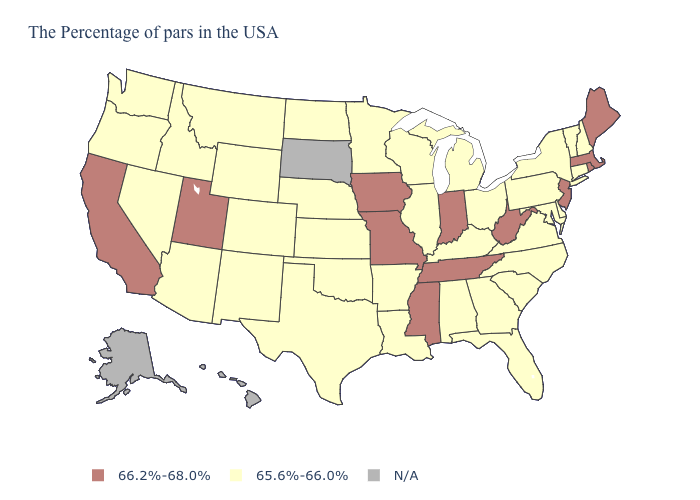What is the highest value in the USA?
Be succinct. 66.2%-68.0%. What is the lowest value in the USA?
Answer briefly. 65.6%-66.0%. Which states have the lowest value in the USA?
Concise answer only. New Hampshire, Vermont, Connecticut, New York, Delaware, Maryland, Pennsylvania, Virginia, North Carolina, South Carolina, Ohio, Florida, Georgia, Michigan, Kentucky, Alabama, Wisconsin, Illinois, Louisiana, Arkansas, Minnesota, Kansas, Nebraska, Oklahoma, Texas, North Dakota, Wyoming, Colorado, New Mexico, Montana, Arizona, Idaho, Nevada, Washington, Oregon. Name the states that have a value in the range 65.6%-66.0%?
Short answer required. New Hampshire, Vermont, Connecticut, New York, Delaware, Maryland, Pennsylvania, Virginia, North Carolina, South Carolina, Ohio, Florida, Georgia, Michigan, Kentucky, Alabama, Wisconsin, Illinois, Louisiana, Arkansas, Minnesota, Kansas, Nebraska, Oklahoma, Texas, North Dakota, Wyoming, Colorado, New Mexico, Montana, Arizona, Idaho, Nevada, Washington, Oregon. What is the highest value in states that border Georgia?
Quick response, please. 66.2%-68.0%. What is the value of Utah?
Write a very short answer. 66.2%-68.0%. Among the states that border Vermont , which have the highest value?
Quick response, please. Massachusetts. What is the value of Colorado?
Be succinct. 65.6%-66.0%. Name the states that have a value in the range 66.2%-68.0%?
Concise answer only. Maine, Massachusetts, Rhode Island, New Jersey, West Virginia, Indiana, Tennessee, Mississippi, Missouri, Iowa, Utah, California. What is the value of New Mexico?
Concise answer only. 65.6%-66.0%. What is the lowest value in the Northeast?
Be succinct. 65.6%-66.0%. What is the value of Mississippi?
Quick response, please. 66.2%-68.0%. What is the value of South Dakota?
Be succinct. N/A. What is the value of Ohio?
Write a very short answer. 65.6%-66.0%. 